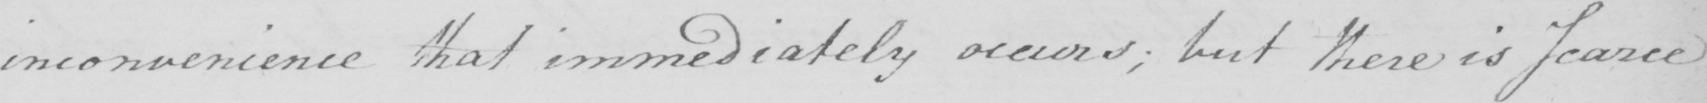Please provide the text content of this handwritten line. inconvenience that immediately occurs ; but there is scarce 